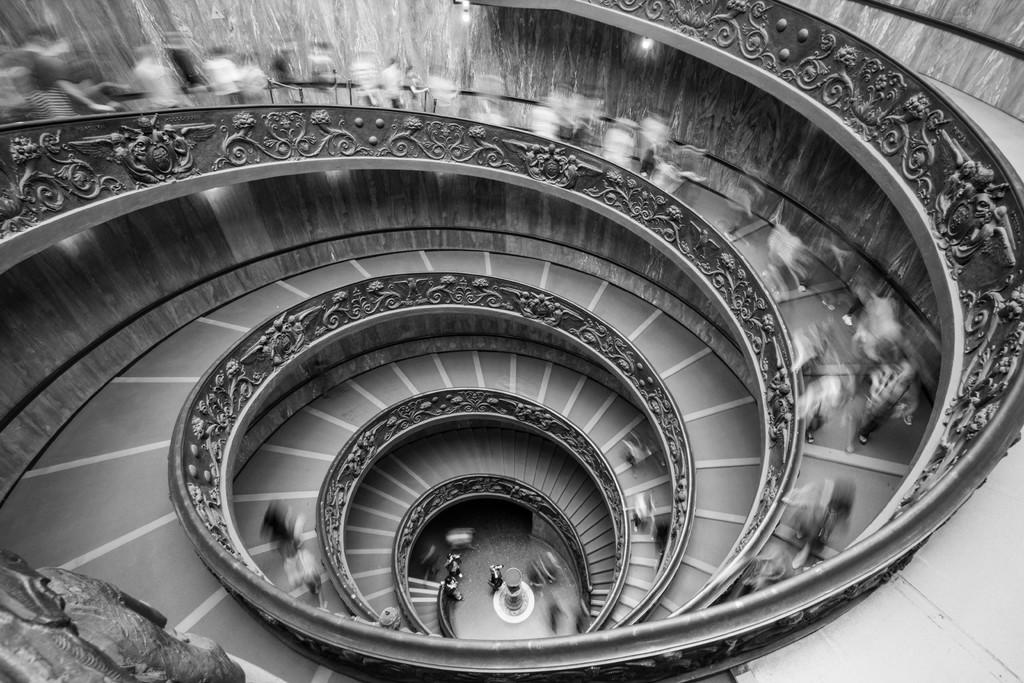What is the color scheme of the image? The image is black and white. What type of staircase is depicted in the image? There is a round staircase in the image. Are there any people in the image? Yes, a group of people are on the staircase. Can you see any guns in the image? No, there are no guns present in the image. What does the aftermath of the event look like in the image? There is no event or aftermath depicted in the image; it features a round staircase with a group of people on it. 